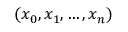<formula> <loc_0><loc_0><loc_500><loc_500>( x _ { 0 } , x _ { 1 } , \dots , x _ { n } )</formula> 